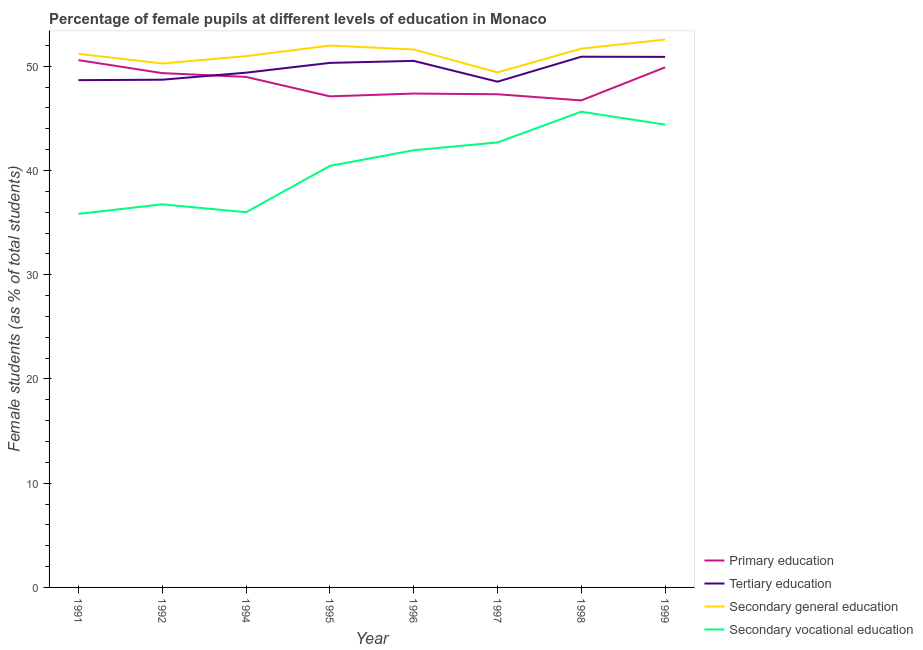How many different coloured lines are there?
Make the answer very short. 4. Does the line corresponding to percentage of female students in secondary education intersect with the line corresponding to percentage of female students in secondary vocational education?
Your answer should be very brief. No. What is the percentage of female students in secondary vocational education in 1998?
Offer a very short reply. 45.64. Across all years, what is the maximum percentage of female students in tertiary education?
Provide a succinct answer. 50.92. Across all years, what is the minimum percentage of female students in secondary vocational education?
Offer a terse response. 35.84. In which year was the percentage of female students in tertiary education maximum?
Make the answer very short. 1998. What is the total percentage of female students in secondary vocational education in the graph?
Offer a terse response. 323.73. What is the difference between the percentage of female students in secondary education in 1992 and that in 1994?
Offer a terse response. -0.7. What is the difference between the percentage of female students in secondary education in 1991 and the percentage of female students in tertiary education in 1998?
Provide a succinct answer. 0.28. What is the average percentage of female students in secondary education per year?
Offer a terse response. 51.22. In the year 1999, what is the difference between the percentage of female students in primary education and percentage of female students in secondary education?
Offer a terse response. -2.67. In how many years, is the percentage of female students in secondary vocational education greater than 42 %?
Ensure brevity in your answer.  3. What is the ratio of the percentage of female students in secondary education in 1996 to that in 1999?
Make the answer very short. 0.98. Is the percentage of female students in secondary education in 1992 less than that in 1996?
Provide a succinct answer. Yes. Is the difference between the percentage of female students in tertiary education in 1991 and 1998 greater than the difference between the percentage of female students in secondary education in 1991 and 1998?
Your answer should be compact. No. What is the difference between the highest and the second highest percentage of female students in primary education?
Provide a succinct answer. 0.69. What is the difference between the highest and the lowest percentage of female students in secondary education?
Give a very brief answer. 3.15. Is the sum of the percentage of female students in secondary vocational education in 1995 and 1999 greater than the maximum percentage of female students in secondary education across all years?
Give a very brief answer. Yes. Is it the case that in every year, the sum of the percentage of female students in tertiary education and percentage of female students in secondary education is greater than the sum of percentage of female students in primary education and percentage of female students in secondary vocational education?
Your answer should be very brief. No. Is it the case that in every year, the sum of the percentage of female students in primary education and percentage of female students in tertiary education is greater than the percentage of female students in secondary education?
Your answer should be very brief. Yes. Does the percentage of female students in secondary vocational education monotonically increase over the years?
Offer a terse response. No. How many years are there in the graph?
Keep it short and to the point. 8. What is the difference between two consecutive major ticks on the Y-axis?
Your response must be concise. 10. Does the graph contain grids?
Ensure brevity in your answer.  No. How many legend labels are there?
Offer a terse response. 4. How are the legend labels stacked?
Offer a very short reply. Vertical. What is the title of the graph?
Provide a succinct answer. Percentage of female pupils at different levels of education in Monaco. Does "International Monetary Fund" appear as one of the legend labels in the graph?
Provide a short and direct response. No. What is the label or title of the X-axis?
Your response must be concise. Year. What is the label or title of the Y-axis?
Ensure brevity in your answer.  Female students (as % of total students). What is the Female students (as % of total students) in Primary education in 1991?
Your answer should be very brief. 50.59. What is the Female students (as % of total students) of Tertiary education in 1991?
Provide a short and direct response. 48.67. What is the Female students (as % of total students) of Secondary general education in 1991?
Make the answer very short. 51.2. What is the Female students (as % of total students) in Secondary vocational education in 1991?
Keep it short and to the point. 35.84. What is the Female students (as % of total students) of Primary education in 1992?
Make the answer very short. 49.35. What is the Female students (as % of total students) of Tertiary education in 1992?
Make the answer very short. 48.71. What is the Female students (as % of total students) in Secondary general education in 1992?
Provide a succinct answer. 50.27. What is the Female students (as % of total students) in Secondary vocational education in 1992?
Keep it short and to the point. 36.76. What is the Female students (as % of total students) in Primary education in 1994?
Give a very brief answer. 48.98. What is the Female students (as % of total students) of Tertiary education in 1994?
Offer a very short reply. 49.39. What is the Female students (as % of total students) of Secondary general education in 1994?
Your response must be concise. 50.98. What is the Female students (as % of total students) of Primary education in 1995?
Make the answer very short. 47.12. What is the Female students (as % of total students) in Tertiary education in 1995?
Offer a very short reply. 50.33. What is the Female students (as % of total students) in Secondary general education in 1995?
Offer a terse response. 51.99. What is the Female students (as % of total students) of Secondary vocational education in 1995?
Make the answer very short. 40.44. What is the Female students (as % of total students) of Primary education in 1996?
Keep it short and to the point. 47.39. What is the Female students (as % of total students) in Tertiary education in 1996?
Ensure brevity in your answer.  50.52. What is the Female students (as % of total students) in Secondary general education in 1996?
Your answer should be compact. 51.61. What is the Female students (as % of total students) of Secondary vocational education in 1996?
Make the answer very short. 41.95. What is the Female students (as % of total students) of Primary education in 1997?
Your answer should be very brief. 47.32. What is the Female students (as % of total students) of Tertiary education in 1997?
Make the answer very short. 48.52. What is the Female students (as % of total students) in Secondary general education in 1997?
Your response must be concise. 49.42. What is the Female students (as % of total students) in Secondary vocational education in 1997?
Your answer should be compact. 42.69. What is the Female students (as % of total students) in Primary education in 1998?
Your answer should be compact. 46.73. What is the Female students (as % of total students) in Tertiary education in 1998?
Your answer should be compact. 50.92. What is the Female students (as % of total students) in Secondary general education in 1998?
Make the answer very short. 51.7. What is the Female students (as % of total students) of Secondary vocational education in 1998?
Offer a very short reply. 45.64. What is the Female students (as % of total students) of Primary education in 1999?
Offer a terse response. 49.9. What is the Female students (as % of total students) in Tertiary education in 1999?
Keep it short and to the point. 50.9. What is the Female students (as % of total students) in Secondary general education in 1999?
Provide a short and direct response. 52.57. What is the Female students (as % of total students) of Secondary vocational education in 1999?
Make the answer very short. 44.4. Across all years, what is the maximum Female students (as % of total students) in Primary education?
Ensure brevity in your answer.  50.59. Across all years, what is the maximum Female students (as % of total students) of Tertiary education?
Make the answer very short. 50.92. Across all years, what is the maximum Female students (as % of total students) in Secondary general education?
Offer a terse response. 52.57. Across all years, what is the maximum Female students (as % of total students) in Secondary vocational education?
Ensure brevity in your answer.  45.64. Across all years, what is the minimum Female students (as % of total students) of Primary education?
Provide a succinct answer. 46.73. Across all years, what is the minimum Female students (as % of total students) in Tertiary education?
Provide a succinct answer. 48.52. Across all years, what is the minimum Female students (as % of total students) of Secondary general education?
Offer a very short reply. 49.42. Across all years, what is the minimum Female students (as % of total students) of Secondary vocational education?
Offer a very short reply. 35.84. What is the total Female students (as % of total students) in Primary education in the graph?
Keep it short and to the point. 387.37. What is the total Female students (as % of total students) of Tertiary education in the graph?
Offer a very short reply. 397.97. What is the total Female students (as % of total students) of Secondary general education in the graph?
Your answer should be very brief. 409.72. What is the total Female students (as % of total students) in Secondary vocational education in the graph?
Provide a succinct answer. 323.73. What is the difference between the Female students (as % of total students) of Primary education in 1991 and that in 1992?
Give a very brief answer. 1.25. What is the difference between the Female students (as % of total students) in Tertiary education in 1991 and that in 1992?
Make the answer very short. -0.04. What is the difference between the Female students (as % of total students) of Secondary general education in 1991 and that in 1992?
Ensure brevity in your answer.  0.92. What is the difference between the Female students (as % of total students) in Secondary vocational education in 1991 and that in 1992?
Your response must be concise. -0.92. What is the difference between the Female students (as % of total students) of Primary education in 1991 and that in 1994?
Make the answer very short. 1.61. What is the difference between the Female students (as % of total students) in Tertiary education in 1991 and that in 1994?
Offer a very short reply. -0.72. What is the difference between the Female students (as % of total students) in Secondary general education in 1991 and that in 1994?
Give a very brief answer. 0.22. What is the difference between the Female students (as % of total students) of Secondary vocational education in 1991 and that in 1994?
Provide a short and direct response. -0.16. What is the difference between the Female students (as % of total students) of Primary education in 1991 and that in 1995?
Your answer should be compact. 3.48. What is the difference between the Female students (as % of total students) of Tertiary education in 1991 and that in 1995?
Provide a succinct answer. -1.66. What is the difference between the Female students (as % of total students) in Secondary general education in 1991 and that in 1995?
Provide a short and direct response. -0.79. What is the difference between the Female students (as % of total students) in Secondary vocational education in 1991 and that in 1995?
Your response must be concise. -4.6. What is the difference between the Female students (as % of total students) of Primary education in 1991 and that in 1996?
Provide a short and direct response. 3.21. What is the difference between the Female students (as % of total students) of Tertiary education in 1991 and that in 1996?
Your response must be concise. -1.85. What is the difference between the Female students (as % of total students) of Secondary general education in 1991 and that in 1996?
Offer a very short reply. -0.42. What is the difference between the Female students (as % of total students) of Secondary vocational education in 1991 and that in 1996?
Provide a short and direct response. -6.11. What is the difference between the Female students (as % of total students) in Primary education in 1991 and that in 1997?
Offer a terse response. 3.28. What is the difference between the Female students (as % of total students) of Tertiary education in 1991 and that in 1997?
Give a very brief answer. 0.15. What is the difference between the Female students (as % of total students) of Secondary general education in 1991 and that in 1997?
Your response must be concise. 1.78. What is the difference between the Female students (as % of total students) of Secondary vocational education in 1991 and that in 1997?
Provide a short and direct response. -6.85. What is the difference between the Female students (as % of total students) in Primary education in 1991 and that in 1998?
Your response must be concise. 3.86. What is the difference between the Female students (as % of total students) of Tertiary education in 1991 and that in 1998?
Your answer should be very brief. -2.25. What is the difference between the Female students (as % of total students) of Secondary general education in 1991 and that in 1998?
Make the answer very short. -0.5. What is the difference between the Female students (as % of total students) of Secondary vocational education in 1991 and that in 1998?
Your answer should be compact. -9.8. What is the difference between the Female students (as % of total students) of Primary education in 1991 and that in 1999?
Your answer should be compact. 0.69. What is the difference between the Female students (as % of total students) of Tertiary education in 1991 and that in 1999?
Keep it short and to the point. -2.23. What is the difference between the Female students (as % of total students) of Secondary general education in 1991 and that in 1999?
Ensure brevity in your answer.  -1.37. What is the difference between the Female students (as % of total students) of Secondary vocational education in 1991 and that in 1999?
Keep it short and to the point. -8.56. What is the difference between the Female students (as % of total students) in Primary education in 1992 and that in 1994?
Offer a terse response. 0.37. What is the difference between the Female students (as % of total students) in Tertiary education in 1992 and that in 1994?
Your answer should be compact. -0.68. What is the difference between the Female students (as % of total students) in Secondary general education in 1992 and that in 1994?
Provide a short and direct response. -0.7. What is the difference between the Female students (as % of total students) in Secondary vocational education in 1992 and that in 1994?
Provide a short and direct response. 0.76. What is the difference between the Female students (as % of total students) in Primary education in 1992 and that in 1995?
Your answer should be very brief. 2.23. What is the difference between the Female students (as % of total students) in Tertiary education in 1992 and that in 1995?
Offer a terse response. -1.61. What is the difference between the Female students (as % of total students) in Secondary general education in 1992 and that in 1995?
Your answer should be compact. -1.72. What is the difference between the Female students (as % of total students) of Secondary vocational education in 1992 and that in 1995?
Offer a very short reply. -3.69. What is the difference between the Female students (as % of total students) of Primary education in 1992 and that in 1996?
Keep it short and to the point. 1.96. What is the difference between the Female students (as % of total students) in Tertiary education in 1992 and that in 1996?
Make the answer very short. -1.81. What is the difference between the Female students (as % of total students) of Secondary general education in 1992 and that in 1996?
Keep it short and to the point. -1.34. What is the difference between the Female students (as % of total students) in Secondary vocational education in 1992 and that in 1996?
Your answer should be very brief. -5.19. What is the difference between the Female students (as % of total students) of Primary education in 1992 and that in 1997?
Provide a short and direct response. 2.03. What is the difference between the Female students (as % of total students) in Tertiary education in 1992 and that in 1997?
Provide a succinct answer. 0.19. What is the difference between the Female students (as % of total students) of Secondary general education in 1992 and that in 1997?
Offer a terse response. 0.86. What is the difference between the Female students (as % of total students) in Secondary vocational education in 1992 and that in 1997?
Your answer should be compact. -5.94. What is the difference between the Female students (as % of total students) in Primary education in 1992 and that in 1998?
Offer a terse response. 2.62. What is the difference between the Female students (as % of total students) of Tertiary education in 1992 and that in 1998?
Your response must be concise. -2.21. What is the difference between the Female students (as % of total students) of Secondary general education in 1992 and that in 1998?
Offer a terse response. -1.42. What is the difference between the Female students (as % of total students) in Secondary vocational education in 1992 and that in 1998?
Make the answer very short. -8.89. What is the difference between the Female students (as % of total students) of Primary education in 1992 and that in 1999?
Your response must be concise. -0.55. What is the difference between the Female students (as % of total students) in Tertiary education in 1992 and that in 1999?
Provide a short and direct response. -2.19. What is the difference between the Female students (as % of total students) of Secondary general education in 1992 and that in 1999?
Provide a short and direct response. -2.29. What is the difference between the Female students (as % of total students) of Secondary vocational education in 1992 and that in 1999?
Offer a very short reply. -7.64. What is the difference between the Female students (as % of total students) in Primary education in 1994 and that in 1995?
Ensure brevity in your answer.  1.86. What is the difference between the Female students (as % of total students) of Tertiary education in 1994 and that in 1995?
Your answer should be compact. -0.94. What is the difference between the Female students (as % of total students) in Secondary general education in 1994 and that in 1995?
Offer a terse response. -1.01. What is the difference between the Female students (as % of total students) of Secondary vocational education in 1994 and that in 1995?
Give a very brief answer. -4.44. What is the difference between the Female students (as % of total students) in Primary education in 1994 and that in 1996?
Ensure brevity in your answer.  1.6. What is the difference between the Female students (as % of total students) of Tertiary education in 1994 and that in 1996?
Provide a succinct answer. -1.13. What is the difference between the Female students (as % of total students) in Secondary general education in 1994 and that in 1996?
Offer a very short reply. -0.64. What is the difference between the Female students (as % of total students) of Secondary vocational education in 1994 and that in 1996?
Provide a succinct answer. -5.95. What is the difference between the Female students (as % of total students) of Primary education in 1994 and that in 1997?
Offer a terse response. 1.66. What is the difference between the Female students (as % of total students) of Tertiary education in 1994 and that in 1997?
Ensure brevity in your answer.  0.86. What is the difference between the Female students (as % of total students) in Secondary general education in 1994 and that in 1997?
Give a very brief answer. 1.56. What is the difference between the Female students (as % of total students) of Secondary vocational education in 1994 and that in 1997?
Give a very brief answer. -6.69. What is the difference between the Female students (as % of total students) of Primary education in 1994 and that in 1998?
Offer a terse response. 2.25. What is the difference between the Female students (as % of total students) of Tertiary education in 1994 and that in 1998?
Keep it short and to the point. -1.53. What is the difference between the Female students (as % of total students) in Secondary general education in 1994 and that in 1998?
Offer a very short reply. -0.72. What is the difference between the Female students (as % of total students) of Secondary vocational education in 1994 and that in 1998?
Offer a terse response. -9.64. What is the difference between the Female students (as % of total students) in Primary education in 1994 and that in 1999?
Make the answer very short. -0.92. What is the difference between the Female students (as % of total students) of Tertiary education in 1994 and that in 1999?
Offer a very short reply. -1.52. What is the difference between the Female students (as % of total students) in Secondary general education in 1994 and that in 1999?
Offer a very short reply. -1.59. What is the difference between the Female students (as % of total students) in Secondary vocational education in 1994 and that in 1999?
Give a very brief answer. -8.4. What is the difference between the Female students (as % of total students) in Primary education in 1995 and that in 1996?
Your answer should be very brief. -0.27. What is the difference between the Female students (as % of total students) in Tertiary education in 1995 and that in 1996?
Your answer should be compact. -0.19. What is the difference between the Female students (as % of total students) of Secondary general education in 1995 and that in 1996?
Make the answer very short. 0.38. What is the difference between the Female students (as % of total students) in Secondary vocational education in 1995 and that in 1996?
Make the answer very short. -1.5. What is the difference between the Female students (as % of total students) in Primary education in 1995 and that in 1997?
Make the answer very short. -0.2. What is the difference between the Female students (as % of total students) in Tertiary education in 1995 and that in 1997?
Keep it short and to the point. 1.8. What is the difference between the Female students (as % of total students) in Secondary general education in 1995 and that in 1997?
Ensure brevity in your answer.  2.57. What is the difference between the Female students (as % of total students) of Secondary vocational education in 1995 and that in 1997?
Offer a terse response. -2.25. What is the difference between the Female students (as % of total students) in Primary education in 1995 and that in 1998?
Your answer should be very brief. 0.39. What is the difference between the Female students (as % of total students) in Tertiary education in 1995 and that in 1998?
Offer a terse response. -0.59. What is the difference between the Female students (as % of total students) in Secondary general education in 1995 and that in 1998?
Your answer should be compact. 0.29. What is the difference between the Female students (as % of total students) of Secondary vocational education in 1995 and that in 1998?
Ensure brevity in your answer.  -5.2. What is the difference between the Female students (as % of total students) in Primary education in 1995 and that in 1999?
Ensure brevity in your answer.  -2.78. What is the difference between the Female students (as % of total students) of Tertiary education in 1995 and that in 1999?
Your response must be concise. -0.58. What is the difference between the Female students (as % of total students) in Secondary general education in 1995 and that in 1999?
Ensure brevity in your answer.  -0.58. What is the difference between the Female students (as % of total students) in Secondary vocational education in 1995 and that in 1999?
Your answer should be compact. -3.96. What is the difference between the Female students (as % of total students) in Primary education in 1996 and that in 1997?
Offer a very short reply. 0.07. What is the difference between the Female students (as % of total students) in Tertiary education in 1996 and that in 1997?
Your response must be concise. 2. What is the difference between the Female students (as % of total students) of Secondary general education in 1996 and that in 1997?
Provide a short and direct response. 2.2. What is the difference between the Female students (as % of total students) in Secondary vocational education in 1996 and that in 1997?
Provide a short and direct response. -0.74. What is the difference between the Female students (as % of total students) of Primary education in 1996 and that in 1998?
Your answer should be very brief. 0.66. What is the difference between the Female students (as % of total students) of Tertiary education in 1996 and that in 1998?
Your answer should be compact. -0.4. What is the difference between the Female students (as % of total students) of Secondary general education in 1996 and that in 1998?
Your answer should be compact. -0.09. What is the difference between the Female students (as % of total students) in Secondary vocational education in 1996 and that in 1998?
Offer a terse response. -3.7. What is the difference between the Female students (as % of total students) of Primary education in 1996 and that in 1999?
Make the answer very short. -2.52. What is the difference between the Female students (as % of total students) in Tertiary education in 1996 and that in 1999?
Your answer should be compact. -0.39. What is the difference between the Female students (as % of total students) of Secondary general education in 1996 and that in 1999?
Your answer should be compact. -0.96. What is the difference between the Female students (as % of total students) in Secondary vocational education in 1996 and that in 1999?
Ensure brevity in your answer.  -2.45. What is the difference between the Female students (as % of total students) in Primary education in 1997 and that in 1998?
Your answer should be very brief. 0.59. What is the difference between the Female students (as % of total students) in Tertiary education in 1997 and that in 1998?
Offer a terse response. -2.4. What is the difference between the Female students (as % of total students) of Secondary general education in 1997 and that in 1998?
Ensure brevity in your answer.  -2.28. What is the difference between the Female students (as % of total students) of Secondary vocational education in 1997 and that in 1998?
Your answer should be compact. -2.95. What is the difference between the Female students (as % of total students) in Primary education in 1997 and that in 1999?
Give a very brief answer. -2.58. What is the difference between the Female students (as % of total students) in Tertiary education in 1997 and that in 1999?
Make the answer very short. -2.38. What is the difference between the Female students (as % of total students) of Secondary general education in 1997 and that in 1999?
Ensure brevity in your answer.  -3.15. What is the difference between the Female students (as % of total students) in Secondary vocational education in 1997 and that in 1999?
Offer a terse response. -1.71. What is the difference between the Female students (as % of total students) in Primary education in 1998 and that in 1999?
Your answer should be very brief. -3.17. What is the difference between the Female students (as % of total students) in Tertiary education in 1998 and that in 1999?
Your answer should be compact. 0.01. What is the difference between the Female students (as % of total students) in Secondary general education in 1998 and that in 1999?
Your answer should be very brief. -0.87. What is the difference between the Female students (as % of total students) in Secondary vocational education in 1998 and that in 1999?
Your response must be concise. 1.24. What is the difference between the Female students (as % of total students) in Primary education in 1991 and the Female students (as % of total students) in Tertiary education in 1992?
Offer a terse response. 1.88. What is the difference between the Female students (as % of total students) of Primary education in 1991 and the Female students (as % of total students) of Secondary general education in 1992?
Give a very brief answer. 0.32. What is the difference between the Female students (as % of total students) in Primary education in 1991 and the Female students (as % of total students) in Secondary vocational education in 1992?
Ensure brevity in your answer.  13.84. What is the difference between the Female students (as % of total students) in Tertiary education in 1991 and the Female students (as % of total students) in Secondary general education in 1992?
Make the answer very short. -1.6. What is the difference between the Female students (as % of total students) of Tertiary education in 1991 and the Female students (as % of total students) of Secondary vocational education in 1992?
Give a very brief answer. 11.91. What is the difference between the Female students (as % of total students) of Secondary general education in 1991 and the Female students (as % of total students) of Secondary vocational education in 1992?
Ensure brevity in your answer.  14.44. What is the difference between the Female students (as % of total students) of Primary education in 1991 and the Female students (as % of total students) of Tertiary education in 1994?
Offer a very short reply. 1.2. What is the difference between the Female students (as % of total students) of Primary education in 1991 and the Female students (as % of total students) of Secondary general education in 1994?
Keep it short and to the point. -0.38. What is the difference between the Female students (as % of total students) of Primary education in 1991 and the Female students (as % of total students) of Secondary vocational education in 1994?
Keep it short and to the point. 14.59. What is the difference between the Female students (as % of total students) in Tertiary education in 1991 and the Female students (as % of total students) in Secondary general education in 1994?
Provide a succinct answer. -2.31. What is the difference between the Female students (as % of total students) in Tertiary education in 1991 and the Female students (as % of total students) in Secondary vocational education in 1994?
Make the answer very short. 12.67. What is the difference between the Female students (as % of total students) in Secondary general education in 1991 and the Female students (as % of total students) in Secondary vocational education in 1994?
Make the answer very short. 15.2. What is the difference between the Female students (as % of total students) in Primary education in 1991 and the Female students (as % of total students) in Tertiary education in 1995?
Your answer should be very brief. 0.27. What is the difference between the Female students (as % of total students) in Primary education in 1991 and the Female students (as % of total students) in Secondary general education in 1995?
Offer a terse response. -1.4. What is the difference between the Female students (as % of total students) in Primary education in 1991 and the Female students (as % of total students) in Secondary vocational education in 1995?
Keep it short and to the point. 10.15. What is the difference between the Female students (as % of total students) in Tertiary education in 1991 and the Female students (as % of total students) in Secondary general education in 1995?
Ensure brevity in your answer.  -3.32. What is the difference between the Female students (as % of total students) in Tertiary education in 1991 and the Female students (as % of total students) in Secondary vocational education in 1995?
Your answer should be very brief. 8.23. What is the difference between the Female students (as % of total students) of Secondary general education in 1991 and the Female students (as % of total students) of Secondary vocational education in 1995?
Your answer should be compact. 10.75. What is the difference between the Female students (as % of total students) of Primary education in 1991 and the Female students (as % of total students) of Tertiary education in 1996?
Your response must be concise. 0.07. What is the difference between the Female students (as % of total students) of Primary education in 1991 and the Female students (as % of total students) of Secondary general education in 1996?
Give a very brief answer. -1.02. What is the difference between the Female students (as % of total students) of Primary education in 1991 and the Female students (as % of total students) of Secondary vocational education in 1996?
Provide a short and direct response. 8.64. What is the difference between the Female students (as % of total students) of Tertiary education in 1991 and the Female students (as % of total students) of Secondary general education in 1996?
Keep it short and to the point. -2.94. What is the difference between the Female students (as % of total students) of Tertiary education in 1991 and the Female students (as % of total students) of Secondary vocational education in 1996?
Provide a short and direct response. 6.72. What is the difference between the Female students (as % of total students) of Secondary general education in 1991 and the Female students (as % of total students) of Secondary vocational education in 1996?
Provide a succinct answer. 9.25. What is the difference between the Female students (as % of total students) of Primary education in 1991 and the Female students (as % of total students) of Tertiary education in 1997?
Make the answer very short. 2.07. What is the difference between the Female students (as % of total students) of Primary education in 1991 and the Female students (as % of total students) of Secondary general education in 1997?
Offer a very short reply. 1.18. What is the difference between the Female students (as % of total students) of Primary education in 1991 and the Female students (as % of total students) of Secondary vocational education in 1997?
Provide a short and direct response. 7.9. What is the difference between the Female students (as % of total students) in Tertiary education in 1991 and the Female students (as % of total students) in Secondary general education in 1997?
Your response must be concise. -0.74. What is the difference between the Female students (as % of total students) of Tertiary education in 1991 and the Female students (as % of total students) of Secondary vocational education in 1997?
Make the answer very short. 5.98. What is the difference between the Female students (as % of total students) in Secondary general education in 1991 and the Female students (as % of total students) in Secondary vocational education in 1997?
Ensure brevity in your answer.  8.5. What is the difference between the Female students (as % of total students) in Primary education in 1991 and the Female students (as % of total students) in Tertiary education in 1998?
Offer a terse response. -0.33. What is the difference between the Female students (as % of total students) in Primary education in 1991 and the Female students (as % of total students) in Secondary general education in 1998?
Give a very brief answer. -1.1. What is the difference between the Female students (as % of total students) in Primary education in 1991 and the Female students (as % of total students) in Secondary vocational education in 1998?
Your answer should be very brief. 4.95. What is the difference between the Female students (as % of total students) of Tertiary education in 1991 and the Female students (as % of total students) of Secondary general education in 1998?
Offer a terse response. -3.03. What is the difference between the Female students (as % of total students) of Tertiary education in 1991 and the Female students (as % of total students) of Secondary vocational education in 1998?
Your response must be concise. 3.03. What is the difference between the Female students (as % of total students) in Secondary general education in 1991 and the Female students (as % of total students) in Secondary vocational education in 1998?
Provide a short and direct response. 5.55. What is the difference between the Female students (as % of total students) in Primary education in 1991 and the Female students (as % of total students) in Tertiary education in 1999?
Your answer should be very brief. -0.31. What is the difference between the Female students (as % of total students) in Primary education in 1991 and the Female students (as % of total students) in Secondary general education in 1999?
Provide a short and direct response. -1.98. What is the difference between the Female students (as % of total students) of Primary education in 1991 and the Female students (as % of total students) of Secondary vocational education in 1999?
Your response must be concise. 6.19. What is the difference between the Female students (as % of total students) in Tertiary education in 1991 and the Female students (as % of total students) in Secondary general education in 1999?
Give a very brief answer. -3.9. What is the difference between the Female students (as % of total students) in Tertiary education in 1991 and the Female students (as % of total students) in Secondary vocational education in 1999?
Offer a terse response. 4.27. What is the difference between the Female students (as % of total students) of Secondary general education in 1991 and the Female students (as % of total students) of Secondary vocational education in 1999?
Your answer should be very brief. 6.79. What is the difference between the Female students (as % of total students) in Primary education in 1992 and the Female students (as % of total students) in Tertiary education in 1994?
Provide a short and direct response. -0.04. What is the difference between the Female students (as % of total students) of Primary education in 1992 and the Female students (as % of total students) of Secondary general education in 1994?
Offer a terse response. -1.63. What is the difference between the Female students (as % of total students) in Primary education in 1992 and the Female students (as % of total students) in Secondary vocational education in 1994?
Give a very brief answer. 13.35. What is the difference between the Female students (as % of total students) in Tertiary education in 1992 and the Female students (as % of total students) in Secondary general education in 1994?
Keep it short and to the point. -2.26. What is the difference between the Female students (as % of total students) of Tertiary education in 1992 and the Female students (as % of total students) of Secondary vocational education in 1994?
Ensure brevity in your answer.  12.71. What is the difference between the Female students (as % of total students) of Secondary general education in 1992 and the Female students (as % of total students) of Secondary vocational education in 1994?
Give a very brief answer. 14.27. What is the difference between the Female students (as % of total students) of Primary education in 1992 and the Female students (as % of total students) of Tertiary education in 1995?
Your answer should be very brief. -0.98. What is the difference between the Female students (as % of total students) in Primary education in 1992 and the Female students (as % of total students) in Secondary general education in 1995?
Offer a very short reply. -2.64. What is the difference between the Female students (as % of total students) of Primary education in 1992 and the Female students (as % of total students) of Secondary vocational education in 1995?
Ensure brevity in your answer.  8.9. What is the difference between the Female students (as % of total students) in Tertiary education in 1992 and the Female students (as % of total students) in Secondary general education in 1995?
Provide a short and direct response. -3.28. What is the difference between the Female students (as % of total students) in Tertiary education in 1992 and the Female students (as % of total students) in Secondary vocational education in 1995?
Ensure brevity in your answer.  8.27. What is the difference between the Female students (as % of total students) of Secondary general education in 1992 and the Female students (as % of total students) of Secondary vocational education in 1995?
Offer a very short reply. 9.83. What is the difference between the Female students (as % of total students) in Primary education in 1992 and the Female students (as % of total students) in Tertiary education in 1996?
Keep it short and to the point. -1.17. What is the difference between the Female students (as % of total students) of Primary education in 1992 and the Female students (as % of total students) of Secondary general education in 1996?
Offer a very short reply. -2.26. What is the difference between the Female students (as % of total students) in Primary education in 1992 and the Female students (as % of total students) in Secondary vocational education in 1996?
Your response must be concise. 7.4. What is the difference between the Female students (as % of total students) of Tertiary education in 1992 and the Female students (as % of total students) of Secondary general education in 1996?
Provide a succinct answer. -2.9. What is the difference between the Female students (as % of total students) in Tertiary education in 1992 and the Female students (as % of total students) in Secondary vocational education in 1996?
Your response must be concise. 6.76. What is the difference between the Female students (as % of total students) in Secondary general education in 1992 and the Female students (as % of total students) in Secondary vocational education in 1996?
Provide a succinct answer. 8.32. What is the difference between the Female students (as % of total students) in Primary education in 1992 and the Female students (as % of total students) in Tertiary education in 1997?
Provide a succinct answer. 0.82. What is the difference between the Female students (as % of total students) of Primary education in 1992 and the Female students (as % of total students) of Secondary general education in 1997?
Provide a short and direct response. -0.07. What is the difference between the Female students (as % of total students) of Primary education in 1992 and the Female students (as % of total students) of Secondary vocational education in 1997?
Make the answer very short. 6.65. What is the difference between the Female students (as % of total students) in Tertiary education in 1992 and the Female students (as % of total students) in Secondary general education in 1997?
Provide a short and direct response. -0.7. What is the difference between the Female students (as % of total students) of Tertiary education in 1992 and the Female students (as % of total students) of Secondary vocational education in 1997?
Your answer should be very brief. 6.02. What is the difference between the Female students (as % of total students) in Secondary general education in 1992 and the Female students (as % of total students) in Secondary vocational education in 1997?
Make the answer very short. 7.58. What is the difference between the Female students (as % of total students) of Primary education in 1992 and the Female students (as % of total students) of Tertiary education in 1998?
Offer a terse response. -1.57. What is the difference between the Female students (as % of total students) of Primary education in 1992 and the Female students (as % of total students) of Secondary general education in 1998?
Provide a succinct answer. -2.35. What is the difference between the Female students (as % of total students) of Primary education in 1992 and the Female students (as % of total students) of Secondary vocational education in 1998?
Offer a terse response. 3.7. What is the difference between the Female students (as % of total students) in Tertiary education in 1992 and the Female students (as % of total students) in Secondary general education in 1998?
Give a very brief answer. -2.98. What is the difference between the Female students (as % of total students) in Tertiary education in 1992 and the Female students (as % of total students) in Secondary vocational education in 1998?
Your answer should be compact. 3.07. What is the difference between the Female students (as % of total students) of Secondary general education in 1992 and the Female students (as % of total students) of Secondary vocational education in 1998?
Your answer should be compact. 4.63. What is the difference between the Female students (as % of total students) of Primary education in 1992 and the Female students (as % of total students) of Tertiary education in 1999?
Offer a terse response. -1.56. What is the difference between the Female students (as % of total students) in Primary education in 1992 and the Female students (as % of total students) in Secondary general education in 1999?
Make the answer very short. -3.22. What is the difference between the Female students (as % of total students) of Primary education in 1992 and the Female students (as % of total students) of Secondary vocational education in 1999?
Your answer should be compact. 4.95. What is the difference between the Female students (as % of total students) of Tertiary education in 1992 and the Female students (as % of total students) of Secondary general education in 1999?
Provide a succinct answer. -3.85. What is the difference between the Female students (as % of total students) of Tertiary education in 1992 and the Female students (as % of total students) of Secondary vocational education in 1999?
Your response must be concise. 4.31. What is the difference between the Female students (as % of total students) of Secondary general education in 1992 and the Female students (as % of total students) of Secondary vocational education in 1999?
Your answer should be compact. 5.87. What is the difference between the Female students (as % of total students) in Primary education in 1994 and the Female students (as % of total students) in Tertiary education in 1995?
Offer a terse response. -1.35. What is the difference between the Female students (as % of total students) of Primary education in 1994 and the Female students (as % of total students) of Secondary general education in 1995?
Make the answer very short. -3.01. What is the difference between the Female students (as % of total students) of Primary education in 1994 and the Female students (as % of total students) of Secondary vocational education in 1995?
Ensure brevity in your answer.  8.54. What is the difference between the Female students (as % of total students) of Tertiary education in 1994 and the Female students (as % of total students) of Secondary general education in 1995?
Your answer should be compact. -2.6. What is the difference between the Female students (as % of total students) in Tertiary education in 1994 and the Female students (as % of total students) in Secondary vocational education in 1995?
Offer a terse response. 8.94. What is the difference between the Female students (as % of total students) in Secondary general education in 1994 and the Female students (as % of total students) in Secondary vocational education in 1995?
Offer a very short reply. 10.53. What is the difference between the Female students (as % of total students) in Primary education in 1994 and the Female students (as % of total students) in Tertiary education in 1996?
Your response must be concise. -1.54. What is the difference between the Female students (as % of total students) of Primary education in 1994 and the Female students (as % of total students) of Secondary general education in 1996?
Your answer should be compact. -2.63. What is the difference between the Female students (as % of total students) of Primary education in 1994 and the Female students (as % of total students) of Secondary vocational education in 1996?
Offer a terse response. 7.03. What is the difference between the Female students (as % of total students) of Tertiary education in 1994 and the Female students (as % of total students) of Secondary general education in 1996?
Offer a very short reply. -2.22. What is the difference between the Female students (as % of total students) in Tertiary education in 1994 and the Female students (as % of total students) in Secondary vocational education in 1996?
Make the answer very short. 7.44. What is the difference between the Female students (as % of total students) of Secondary general education in 1994 and the Female students (as % of total students) of Secondary vocational education in 1996?
Make the answer very short. 9.03. What is the difference between the Female students (as % of total students) of Primary education in 1994 and the Female students (as % of total students) of Tertiary education in 1997?
Your answer should be compact. 0.46. What is the difference between the Female students (as % of total students) in Primary education in 1994 and the Female students (as % of total students) in Secondary general education in 1997?
Your response must be concise. -0.43. What is the difference between the Female students (as % of total students) in Primary education in 1994 and the Female students (as % of total students) in Secondary vocational education in 1997?
Make the answer very short. 6.29. What is the difference between the Female students (as % of total students) in Tertiary education in 1994 and the Female students (as % of total students) in Secondary general education in 1997?
Provide a short and direct response. -0.03. What is the difference between the Female students (as % of total students) in Tertiary education in 1994 and the Female students (as % of total students) in Secondary vocational education in 1997?
Your answer should be compact. 6.7. What is the difference between the Female students (as % of total students) of Secondary general education in 1994 and the Female students (as % of total students) of Secondary vocational education in 1997?
Make the answer very short. 8.28. What is the difference between the Female students (as % of total students) in Primary education in 1994 and the Female students (as % of total students) in Tertiary education in 1998?
Keep it short and to the point. -1.94. What is the difference between the Female students (as % of total students) in Primary education in 1994 and the Female students (as % of total students) in Secondary general education in 1998?
Your answer should be compact. -2.72. What is the difference between the Female students (as % of total students) of Primary education in 1994 and the Female students (as % of total students) of Secondary vocational education in 1998?
Offer a terse response. 3.34. What is the difference between the Female students (as % of total students) in Tertiary education in 1994 and the Female students (as % of total students) in Secondary general education in 1998?
Keep it short and to the point. -2.31. What is the difference between the Female students (as % of total students) of Tertiary education in 1994 and the Female students (as % of total students) of Secondary vocational education in 1998?
Provide a succinct answer. 3.74. What is the difference between the Female students (as % of total students) in Secondary general education in 1994 and the Female students (as % of total students) in Secondary vocational education in 1998?
Give a very brief answer. 5.33. What is the difference between the Female students (as % of total students) in Primary education in 1994 and the Female students (as % of total students) in Tertiary education in 1999?
Offer a terse response. -1.92. What is the difference between the Female students (as % of total students) in Primary education in 1994 and the Female students (as % of total students) in Secondary general education in 1999?
Your answer should be very brief. -3.59. What is the difference between the Female students (as % of total students) of Primary education in 1994 and the Female students (as % of total students) of Secondary vocational education in 1999?
Provide a short and direct response. 4.58. What is the difference between the Female students (as % of total students) of Tertiary education in 1994 and the Female students (as % of total students) of Secondary general education in 1999?
Your answer should be compact. -3.18. What is the difference between the Female students (as % of total students) of Tertiary education in 1994 and the Female students (as % of total students) of Secondary vocational education in 1999?
Make the answer very short. 4.99. What is the difference between the Female students (as % of total students) of Secondary general education in 1994 and the Female students (as % of total students) of Secondary vocational education in 1999?
Your answer should be compact. 6.57. What is the difference between the Female students (as % of total students) of Primary education in 1995 and the Female students (as % of total students) of Tertiary education in 1996?
Ensure brevity in your answer.  -3.4. What is the difference between the Female students (as % of total students) in Primary education in 1995 and the Female students (as % of total students) in Secondary general education in 1996?
Your answer should be compact. -4.5. What is the difference between the Female students (as % of total students) of Primary education in 1995 and the Female students (as % of total students) of Secondary vocational education in 1996?
Make the answer very short. 5.17. What is the difference between the Female students (as % of total students) in Tertiary education in 1995 and the Female students (as % of total students) in Secondary general education in 1996?
Offer a very short reply. -1.28. What is the difference between the Female students (as % of total students) in Tertiary education in 1995 and the Female students (as % of total students) in Secondary vocational education in 1996?
Provide a short and direct response. 8.38. What is the difference between the Female students (as % of total students) of Secondary general education in 1995 and the Female students (as % of total students) of Secondary vocational education in 1996?
Make the answer very short. 10.04. What is the difference between the Female students (as % of total students) of Primary education in 1995 and the Female students (as % of total students) of Tertiary education in 1997?
Provide a succinct answer. -1.41. What is the difference between the Female students (as % of total students) of Primary education in 1995 and the Female students (as % of total students) of Secondary general education in 1997?
Your response must be concise. -2.3. What is the difference between the Female students (as % of total students) of Primary education in 1995 and the Female students (as % of total students) of Secondary vocational education in 1997?
Your answer should be very brief. 4.42. What is the difference between the Female students (as % of total students) of Tertiary education in 1995 and the Female students (as % of total students) of Secondary general education in 1997?
Offer a terse response. 0.91. What is the difference between the Female students (as % of total students) in Tertiary education in 1995 and the Female students (as % of total students) in Secondary vocational education in 1997?
Offer a terse response. 7.63. What is the difference between the Female students (as % of total students) of Secondary general education in 1995 and the Female students (as % of total students) of Secondary vocational education in 1997?
Ensure brevity in your answer.  9.3. What is the difference between the Female students (as % of total students) of Primary education in 1995 and the Female students (as % of total students) of Tertiary education in 1998?
Your answer should be very brief. -3.8. What is the difference between the Female students (as % of total students) of Primary education in 1995 and the Female students (as % of total students) of Secondary general education in 1998?
Your answer should be very brief. -4.58. What is the difference between the Female students (as % of total students) in Primary education in 1995 and the Female students (as % of total students) in Secondary vocational education in 1998?
Your response must be concise. 1.47. What is the difference between the Female students (as % of total students) in Tertiary education in 1995 and the Female students (as % of total students) in Secondary general education in 1998?
Your answer should be very brief. -1.37. What is the difference between the Female students (as % of total students) of Tertiary education in 1995 and the Female students (as % of total students) of Secondary vocational education in 1998?
Offer a terse response. 4.68. What is the difference between the Female students (as % of total students) of Secondary general education in 1995 and the Female students (as % of total students) of Secondary vocational education in 1998?
Provide a short and direct response. 6.35. What is the difference between the Female students (as % of total students) in Primary education in 1995 and the Female students (as % of total students) in Tertiary education in 1999?
Provide a short and direct response. -3.79. What is the difference between the Female students (as % of total students) of Primary education in 1995 and the Female students (as % of total students) of Secondary general education in 1999?
Offer a very short reply. -5.45. What is the difference between the Female students (as % of total students) in Primary education in 1995 and the Female students (as % of total students) in Secondary vocational education in 1999?
Give a very brief answer. 2.71. What is the difference between the Female students (as % of total students) in Tertiary education in 1995 and the Female students (as % of total students) in Secondary general education in 1999?
Your answer should be compact. -2.24. What is the difference between the Female students (as % of total students) in Tertiary education in 1995 and the Female students (as % of total students) in Secondary vocational education in 1999?
Give a very brief answer. 5.93. What is the difference between the Female students (as % of total students) in Secondary general education in 1995 and the Female students (as % of total students) in Secondary vocational education in 1999?
Your response must be concise. 7.59. What is the difference between the Female students (as % of total students) in Primary education in 1996 and the Female students (as % of total students) in Tertiary education in 1997?
Your answer should be very brief. -1.14. What is the difference between the Female students (as % of total students) in Primary education in 1996 and the Female students (as % of total students) in Secondary general education in 1997?
Your response must be concise. -2.03. What is the difference between the Female students (as % of total students) of Primary education in 1996 and the Female students (as % of total students) of Secondary vocational education in 1997?
Ensure brevity in your answer.  4.69. What is the difference between the Female students (as % of total students) of Tertiary education in 1996 and the Female students (as % of total students) of Secondary general education in 1997?
Your answer should be compact. 1.1. What is the difference between the Female students (as % of total students) in Tertiary education in 1996 and the Female students (as % of total students) in Secondary vocational education in 1997?
Keep it short and to the point. 7.83. What is the difference between the Female students (as % of total students) of Secondary general education in 1996 and the Female students (as % of total students) of Secondary vocational education in 1997?
Offer a terse response. 8.92. What is the difference between the Female students (as % of total students) of Primary education in 1996 and the Female students (as % of total students) of Tertiary education in 1998?
Make the answer very short. -3.53. What is the difference between the Female students (as % of total students) of Primary education in 1996 and the Female students (as % of total students) of Secondary general education in 1998?
Provide a short and direct response. -4.31. What is the difference between the Female students (as % of total students) of Primary education in 1996 and the Female students (as % of total students) of Secondary vocational education in 1998?
Ensure brevity in your answer.  1.74. What is the difference between the Female students (as % of total students) in Tertiary education in 1996 and the Female students (as % of total students) in Secondary general education in 1998?
Keep it short and to the point. -1.18. What is the difference between the Female students (as % of total students) of Tertiary education in 1996 and the Female students (as % of total students) of Secondary vocational education in 1998?
Ensure brevity in your answer.  4.88. What is the difference between the Female students (as % of total students) in Secondary general education in 1996 and the Female students (as % of total students) in Secondary vocational education in 1998?
Give a very brief answer. 5.97. What is the difference between the Female students (as % of total students) in Primary education in 1996 and the Female students (as % of total students) in Tertiary education in 1999?
Your answer should be very brief. -3.52. What is the difference between the Female students (as % of total students) of Primary education in 1996 and the Female students (as % of total students) of Secondary general education in 1999?
Provide a short and direct response. -5.18. What is the difference between the Female students (as % of total students) in Primary education in 1996 and the Female students (as % of total students) in Secondary vocational education in 1999?
Provide a short and direct response. 2.98. What is the difference between the Female students (as % of total students) of Tertiary education in 1996 and the Female students (as % of total students) of Secondary general education in 1999?
Your response must be concise. -2.05. What is the difference between the Female students (as % of total students) of Tertiary education in 1996 and the Female students (as % of total students) of Secondary vocational education in 1999?
Your answer should be very brief. 6.12. What is the difference between the Female students (as % of total students) in Secondary general education in 1996 and the Female students (as % of total students) in Secondary vocational education in 1999?
Your answer should be compact. 7.21. What is the difference between the Female students (as % of total students) in Primary education in 1997 and the Female students (as % of total students) in Tertiary education in 1998?
Your response must be concise. -3.6. What is the difference between the Female students (as % of total students) in Primary education in 1997 and the Female students (as % of total students) in Secondary general education in 1998?
Keep it short and to the point. -4.38. What is the difference between the Female students (as % of total students) in Primary education in 1997 and the Female students (as % of total students) in Secondary vocational education in 1998?
Your answer should be compact. 1.67. What is the difference between the Female students (as % of total students) in Tertiary education in 1997 and the Female students (as % of total students) in Secondary general education in 1998?
Your response must be concise. -3.17. What is the difference between the Female students (as % of total students) of Tertiary education in 1997 and the Female students (as % of total students) of Secondary vocational education in 1998?
Offer a terse response. 2.88. What is the difference between the Female students (as % of total students) in Secondary general education in 1997 and the Female students (as % of total students) in Secondary vocational education in 1998?
Your answer should be compact. 3.77. What is the difference between the Female students (as % of total students) of Primary education in 1997 and the Female students (as % of total students) of Tertiary education in 1999?
Provide a succinct answer. -3.59. What is the difference between the Female students (as % of total students) of Primary education in 1997 and the Female students (as % of total students) of Secondary general education in 1999?
Provide a short and direct response. -5.25. What is the difference between the Female students (as % of total students) in Primary education in 1997 and the Female students (as % of total students) in Secondary vocational education in 1999?
Provide a short and direct response. 2.91. What is the difference between the Female students (as % of total students) in Tertiary education in 1997 and the Female students (as % of total students) in Secondary general education in 1999?
Your response must be concise. -4.04. What is the difference between the Female students (as % of total students) in Tertiary education in 1997 and the Female students (as % of total students) in Secondary vocational education in 1999?
Your response must be concise. 4.12. What is the difference between the Female students (as % of total students) of Secondary general education in 1997 and the Female students (as % of total students) of Secondary vocational education in 1999?
Offer a terse response. 5.01. What is the difference between the Female students (as % of total students) of Primary education in 1998 and the Female students (as % of total students) of Tertiary education in 1999?
Your answer should be very brief. -4.18. What is the difference between the Female students (as % of total students) in Primary education in 1998 and the Female students (as % of total students) in Secondary general education in 1999?
Offer a terse response. -5.84. What is the difference between the Female students (as % of total students) of Primary education in 1998 and the Female students (as % of total students) of Secondary vocational education in 1999?
Offer a terse response. 2.33. What is the difference between the Female students (as % of total students) of Tertiary education in 1998 and the Female students (as % of total students) of Secondary general education in 1999?
Provide a succinct answer. -1.65. What is the difference between the Female students (as % of total students) in Tertiary education in 1998 and the Female students (as % of total students) in Secondary vocational education in 1999?
Offer a terse response. 6.52. What is the difference between the Female students (as % of total students) in Secondary general education in 1998 and the Female students (as % of total students) in Secondary vocational education in 1999?
Your response must be concise. 7.3. What is the average Female students (as % of total students) of Primary education per year?
Provide a short and direct response. 48.42. What is the average Female students (as % of total students) of Tertiary education per year?
Provide a short and direct response. 49.75. What is the average Female students (as % of total students) in Secondary general education per year?
Offer a terse response. 51.22. What is the average Female students (as % of total students) of Secondary vocational education per year?
Your answer should be compact. 40.47. In the year 1991, what is the difference between the Female students (as % of total students) in Primary education and Female students (as % of total students) in Tertiary education?
Your answer should be very brief. 1.92. In the year 1991, what is the difference between the Female students (as % of total students) in Primary education and Female students (as % of total students) in Secondary general education?
Your response must be concise. -0.6. In the year 1991, what is the difference between the Female students (as % of total students) of Primary education and Female students (as % of total students) of Secondary vocational education?
Offer a very short reply. 14.75. In the year 1991, what is the difference between the Female students (as % of total students) of Tertiary education and Female students (as % of total students) of Secondary general education?
Provide a short and direct response. -2.53. In the year 1991, what is the difference between the Female students (as % of total students) in Tertiary education and Female students (as % of total students) in Secondary vocational education?
Your response must be concise. 12.83. In the year 1991, what is the difference between the Female students (as % of total students) in Secondary general education and Female students (as % of total students) in Secondary vocational education?
Provide a succinct answer. 15.36. In the year 1992, what is the difference between the Female students (as % of total students) of Primary education and Female students (as % of total students) of Tertiary education?
Make the answer very short. 0.63. In the year 1992, what is the difference between the Female students (as % of total students) of Primary education and Female students (as % of total students) of Secondary general education?
Your answer should be very brief. -0.93. In the year 1992, what is the difference between the Female students (as % of total students) of Primary education and Female students (as % of total students) of Secondary vocational education?
Provide a short and direct response. 12.59. In the year 1992, what is the difference between the Female students (as % of total students) in Tertiary education and Female students (as % of total students) in Secondary general education?
Your answer should be very brief. -1.56. In the year 1992, what is the difference between the Female students (as % of total students) of Tertiary education and Female students (as % of total students) of Secondary vocational education?
Offer a very short reply. 11.96. In the year 1992, what is the difference between the Female students (as % of total students) in Secondary general education and Female students (as % of total students) in Secondary vocational education?
Your answer should be very brief. 13.52. In the year 1994, what is the difference between the Female students (as % of total students) in Primary education and Female students (as % of total students) in Tertiary education?
Make the answer very short. -0.41. In the year 1994, what is the difference between the Female students (as % of total students) in Primary education and Female students (as % of total students) in Secondary general education?
Offer a very short reply. -1.99. In the year 1994, what is the difference between the Female students (as % of total students) of Primary education and Female students (as % of total students) of Secondary vocational education?
Your answer should be very brief. 12.98. In the year 1994, what is the difference between the Female students (as % of total students) of Tertiary education and Female students (as % of total students) of Secondary general education?
Provide a succinct answer. -1.59. In the year 1994, what is the difference between the Female students (as % of total students) in Tertiary education and Female students (as % of total students) in Secondary vocational education?
Your answer should be compact. 13.39. In the year 1994, what is the difference between the Female students (as % of total students) in Secondary general education and Female students (as % of total students) in Secondary vocational education?
Provide a succinct answer. 14.98. In the year 1995, what is the difference between the Female students (as % of total students) of Primary education and Female students (as % of total students) of Tertiary education?
Give a very brief answer. -3.21. In the year 1995, what is the difference between the Female students (as % of total students) of Primary education and Female students (as % of total students) of Secondary general education?
Give a very brief answer. -4.87. In the year 1995, what is the difference between the Female students (as % of total students) in Primary education and Female students (as % of total students) in Secondary vocational education?
Your answer should be compact. 6.67. In the year 1995, what is the difference between the Female students (as % of total students) of Tertiary education and Female students (as % of total students) of Secondary general education?
Provide a succinct answer. -1.66. In the year 1995, what is the difference between the Female students (as % of total students) of Tertiary education and Female students (as % of total students) of Secondary vocational education?
Provide a short and direct response. 9.88. In the year 1995, what is the difference between the Female students (as % of total students) in Secondary general education and Female students (as % of total students) in Secondary vocational education?
Offer a very short reply. 11.55. In the year 1996, what is the difference between the Female students (as % of total students) of Primary education and Female students (as % of total students) of Tertiary education?
Offer a terse response. -3.13. In the year 1996, what is the difference between the Female students (as % of total students) of Primary education and Female students (as % of total students) of Secondary general education?
Ensure brevity in your answer.  -4.23. In the year 1996, what is the difference between the Female students (as % of total students) in Primary education and Female students (as % of total students) in Secondary vocational education?
Provide a short and direct response. 5.44. In the year 1996, what is the difference between the Female students (as % of total students) of Tertiary education and Female students (as % of total students) of Secondary general education?
Your answer should be compact. -1.09. In the year 1996, what is the difference between the Female students (as % of total students) of Tertiary education and Female students (as % of total students) of Secondary vocational education?
Offer a very short reply. 8.57. In the year 1996, what is the difference between the Female students (as % of total students) of Secondary general education and Female students (as % of total students) of Secondary vocational education?
Your answer should be compact. 9.66. In the year 1997, what is the difference between the Female students (as % of total students) of Primary education and Female students (as % of total students) of Tertiary education?
Your answer should be very brief. -1.21. In the year 1997, what is the difference between the Female students (as % of total students) in Primary education and Female students (as % of total students) in Secondary general education?
Your answer should be very brief. -2.1. In the year 1997, what is the difference between the Female students (as % of total students) of Primary education and Female students (as % of total students) of Secondary vocational education?
Offer a very short reply. 4.62. In the year 1997, what is the difference between the Female students (as % of total students) in Tertiary education and Female students (as % of total students) in Secondary general education?
Keep it short and to the point. -0.89. In the year 1997, what is the difference between the Female students (as % of total students) of Tertiary education and Female students (as % of total students) of Secondary vocational education?
Your response must be concise. 5.83. In the year 1997, what is the difference between the Female students (as % of total students) of Secondary general education and Female students (as % of total students) of Secondary vocational education?
Provide a succinct answer. 6.72. In the year 1998, what is the difference between the Female students (as % of total students) of Primary education and Female students (as % of total students) of Tertiary education?
Your answer should be compact. -4.19. In the year 1998, what is the difference between the Female students (as % of total students) in Primary education and Female students (as % of total students) in Secondary general education?
Provide a short and direct response. -4.97. In the year 1998, what is the difference between the Female students (as % of total students) in Primary education and Female students (as % of total students) in Secondary vocational education?
Offer a terse response. 1.08. In the year 1998, what is the difference between the Female students (as % of total students) in Tertiary education and Female students (as % of total students) in Secondary general education?
Offer a terse response. -0.78. In the year 1998, what is the difference between the Female students (as % of total students) of Tertiary education and Female students (as % of total students) of Secondary vocational education?
Your answer should be very brief. 5.28. In the year 1998, what is the difference between the Female students (as % of total students) in Secondary general education and Female students (as % of total students) in Secondary vocational education?
Make the answer very short. 6.05. In the year 1999, what is the difference between the Female students (as % of total students) of Primary education and Female students (as % of total students) of Tertiary education?
Your response must be concise. -1. In the year 1999, what is the difference between the Female students (as % of total students) in Primary education and Female students (as % of total students) in Secondary general education?
Your answer should be very brief. -2.67. In the year 1999, what is the difference between the Female students (as % of total students) of Primary education and Female students (as % of total students) of Secondary vocational education?
Provide a short and direct response. 5.5. In the year 1999, what is the difference between the Female students (as % of total students) of Tertiary education and Female students (as % of total students) of Secondary general education?
Provide a succinct answer. -1.66. In the year 1999, what is the difference between the Female students (as % of total students) of Tertiary education and Female students (as % of total students) of Secondary vocational education?
Your answer should be compact. 6.5. In the year 1999, what is the difference between the Female students (as % of total students) in Secondary general education and Female students (as % of total students) in Secondary vocational education?
Your response must be concise. 8.17. What is the ratio of the Female students (as % of total students) of Primary education in 1991 to that in 1992?
Your answer should be very brief. 1.03. What is the ratio of the Female students (as % of total students) in Secondary general education in 1991 to that in 1992?
Ensure brevity in your answer.  1.02. What is the ratio of the Female students (as % of total students) of Primary education in 1991 to that in 1994?
Offer a terse response. 1.03. What is the ratio of the Female students (as % of total students) in Tertiary education in 1991 to that in 1994?
Offer a terse response. 0.99. What is the ratio of the Female students (as % of total students) in Secondary general education in 1991 to that in 1994?
Ensure brevity in your answer.  1. What is the ratio of the Female students (as % of total students) in Secondary vocational education in 1991 to that in 1994?
Your response must be concise. 1. What is the ratio of the Female students (as % of total students) in Primary education in 1991 to that in 1995?
Your response must be concise. 1.07. What is the ratio of the Female students (as % of total students) of Tertiary education in 1991 to that in 1995?
Ensure brevity in your answer.  0.97. What is the ratio of the Female students (as % of total students) in Secondary general education in 1991 to that in 1995?
Offer a terse response. 0.98. What is the ratio of the Female students (as % of total students) of Secondary vocational education in 1991 to that in 1995?
Provide a short and direct response. 0.89. What is the ratio of the Female students (as % of total students) in Primary education in 1991 to that in 1996?
Make the answer very short. 1.07. What is the ratio of the Female students (as % of total students) in Tertiary education in 1991 to that in 1996?
Your answer should be very brief. 0.96. What is the ratio of the Female students (as % of total students) of Secondary general education in 1991 to that in 1996?
Your answer should be compact. 0.99. What is the ratio of the Female students (as % of total students) in Secondary vocational education in 1991 to that in 1996?
Your response must be concise. 0.85. What is the ratio of the Female students (as % of total students) in Primary education in 1991 to that in 1997?
Provide a succinct answer. 1.07. What is the ratio of the Female students (as % of total students) in Tertiary education in 1991 to that in 1997?
Provide a succinct answer. 1. What is the ratio of the Female students (as % of total students) in Secondary general education in 1991 to that in 1997?
Provide a succinct answer. 1.04. What is the ratio of the Female students (as % of total students) in Secondary vocational education in 1991 to that in 1997?
Your answer should be compact. 0.84. What is the ratio of the Female students (as % of total students) of Primary education in 1991 to that in 1998?
Provide a short and direct response. 1.08. What is the ratio of the Female students (as % of total students) in Tertiary education in 1991 to that in 1998?
Ensure brevity in your answer.  0.96. What is the ratio of the Female students (as % of total students) in Secondary general education in 1991 to that in 1998?
Ensure brevity in your answer.  0.99. What is the ratio of the Female students (as % of total students) in Secondary vocational education in 1991 to that in 1998?
Your response must be concise. 0.79. What is the ratio of the Female students (as % of total students) of Primary education in 1991 to that in 1999?
Make the answer very short. 1.01. What is the ratio of the Female students (as % of total students) in Tertiary education in 1991 to that in 1999?
Provide a succinct answer. 0.96. What is the ratio of the Female students (as % of total students) of Secondary general education in 1991 to that in 1999?
Make the answer very short. 0.97. What is the ratio of the Female students (as % of total students) of Secondary vocational education in 1991 to that in 1999?
Make the answer very short. 0.81. What is the ratio of the Female students (as % of total students) of Primary education in 1992 to that in 1994?
Keep it short and to the point. 1.01. What is the ratio of the Female students (as % of total students) in Tertiary education in 1992 to that in 1994?
Provide a short and direct response. 0.99. What is the ratio of the Female students (as % of total students) of Secondary general education in 1992 to that in 1994?
Offer a terse response. 0.99. What is the ratio of the Female students (as % of total students) of Secondary vocational education in 1992 to that in 1994?
Your answer should be compact. 1.02. What is the ratio of the Female students (as % of total students) in Primary education in 1992 to that in 1995?
Your response must be concise. 1.05. What is the ratio of the Female students (as % of total students) in Tertiary education in 1992 to that in 1995?
Keep it short and to the point. 0.97. What is the ratio of the Female students (as % of total students) of Secondary vocational education in 1992 to that in 1995?
Your response must be concise. 0.91. What is the ratio of the Female students (as % of total students) of Primary education in 1992 to that in 1996?
Give a very brief answer. 1.04. What is the ratio of the Female students (as % of total students) of Tertiary education in 1992 to that in 1996?
Keep it short and to the point. 0.96. What is the ratio of the Female students (as % of total students) of Secondary general education in 1992 to that in 1996?
Offer a very short reply. 0.97. What is the ratio of the Female students (as % of total students) of Secondary vocational education in 1992 to that in 1996?
Offer a terse response. 0.88. What is the ratio of the Female students (as % of total students) in Primary education in 1992 to that in 1997?
Your answer should be compact. 1.04. What is the ratio of the Female students (as % of total students) of Secondary general education in 1992 to that in 1997?
Provide a short and direct response. 1.02. What is the ratio of the Female students (as % of total students) in Secondary vocational education in 1992 to that in 1997?
Your answer should be compact. 0.86. What is the ratio of the Female students (as % of total students) in Primary education in 1992 to that in 1998?
Give a very brief answer. 1.06. What is the ratio of the Female students (as % of total students) in Tertiary education in 1992 to that in 1998?
Offer a very short reply. 0.96. What is the ratio of the Female students (as % of total students) of Secondary general education in 1992 to that in 1998?
Keep it short and to the point. 0.97. What is the ratio of the Female students (as % of total students) of Secondary vocational education in 1992 to that in 1998?
Offer a terse response. 0.81. What is the ratio of the Female students (as % of total students) of Primary education in 1992 to that in 1999?
Your answer should be compact. 0.99. What is the ratio of the Female students (as % of total students) of Tertiary education in 1992 to that in 1999?
Your answer should be compact. 0.96. What is the ratio of the Female students (as % of total students) of Secondary general education in 1992 to that in 1999?
Provide a short and direct response. 0.96. What is the ratio of the Female students (as % of total students) of Secondary vocational education in 1992 to that in 1999?
Make the answer very short. 0.83. What is the ratio of the Female students (as % of total students) in Primary education in 1994 to that in 1995?
Provide a short and direct response. 1.04. What is the ratio of the Female students (as % of total students) of Tertiary education in 1994 to that in 1995?
Offer a terse response. 0.98. What is the ratio of the Female students (as % of total students) of Secondary general education in 1994 to that in 1995?
Offer a terse response. 0.98. What is the ratio of the Female students (as % of total students) of Secondary vocational education in 1994 to that in 1995?
Provide a succinct answer. 0.89. What is the ratio of the Female students (as % of total students) of Primary education in 1994 to that in 1996?
Your answer should be compact. 1.03. What is the ratio of the Female students (as % of total students) in Tertiary education in 1994 to that in 1996?
Make the answer very short. 0.98. What is the ratio of the Female students (as % of total students) in Secondary vocational education in 1994 to that in 1996?
Ensure brevity in your answer.  0.86. What is the ratio of the Female students (as % of total students) of Primary education in 1994 to that in 1997?
Your answer should be compact. 1.04. What is the ratio of the Female students (as % of total students) of Tertiary education in 1994 to that in 1997?
Provide a short and direct response. 1.02. What is the ratio of the Female students (as % of total students) of Secondary general education in 1994 to that in 1997?
Provide a succinct answer. 1.03. What is the ratio of the Female students (as % of total students) in Secondary vocational education in 1994 to that in 1997?
Your answer should be compact. 0.84. What is the ratio of the Female students (as % of total students) of Primary education in 1994 to that in 1998?
Make the answer very short. 1.05. What is the ratio of the Female students (as % of total students) in Tertiary education in 1994 to that in 1998?
Provide a succinct answer. 0.97. What is the ratio of the Female students (as % of total students) in Secondary vocational education in 1994 to that in 1998?
Provide a short and direct response. 0.79. What is the ratio of the Female students (as % of total students) in Primary education in 1994 to that in 1999?
Offer a very short reply. 0.98. What is the ratio of the Female students (as % of total students) in Tertiary education in 1994 to that in 1999?
Provide a succinct answer. 0.97. What is the ratio of the Female students (as % of total students) in Secondary general education in 1994 to that in 1999?
Keep it short and to the point. 0.97. What is the ratio of the Female students (as % of total students) of Secondary vocational education in 1994 to that in 1999?
Make the answer very short. 0.81. What is the ratio of the Female students (as % of total students) in Secondary general education in 1995 to that in 1996?
Give a very brief answer. 1.01. What is the ratio of the Female students (as % of total students) in Secondary vocational education in 1995 to that in 1996?
Make the answer very short. 0.96. What is the ratio of the Female students (as % of total students) in Primary education in 1995 to that in 1997?
Give a very brief answer. 1. What is the ratio of the Female students (as % of total students) of Tertiary education in 1995 to that in 1997?
Give a very brief answer. 1.04. What is the ratio of the Female students (as % of total students) of Secondary general education in 1995 to that in 1997?
Make the answer very short. 1.05. What is the ratio of the Female students (as % of total students) of Secondary vocational education in 1995 to that in 1997?
Offer a terse response. 0.95. What is the ratio of the Female students (as % of total students) of Primary education in 1995 to that in 1998?
Your answer should be compact. 1.01. What is the ratio of the Female students (as % of total students) in Tertiary education in 1995 to that in 1998?
Keep it short and to the point. 0.99. What is the ratio of the Female students (as % of total students) in Secondary general education in 1995 to that in 1998?
Your answer should be very brief. 1.01. What is the ratio of the Female students (as % of total students) of Secondary vocational education in 1995 to that in 1998?
Your answer should be very brief. 0.89. What is the ratio of the Female students (as % of total students) of Primary education in 1995 to that in 1999?
Your answer should be very brief. 0.94. What is the ratio of the Female students (as % of total students) of Tertiary education in 1995 to that in 1999?
Your response must be concise. 0.99. What is the ratio of the Female students (as % of total students) in Secondary general education in 1995 to that in 1999?
Make the answer very short. 0.99. What is the ratio of the Female students (as % of total students) in Secondary vocational education in 1995 to that in 1999?
Your response must be concise. 0.91. What is the ratio of the Female students (as % of total students) in Tertiary education in 1996 to that in 1997?
Your answer should be compact. 1.04. What is the ratio of the Female students (as % of total students) in Secondary general education in 1996 to that in 1997?
Give a very brief answer. 1.04. What is the ratio of the Female students (as % of total students) in Secondary vocational education in 1996 to that in 1997?
Your answer should be compact. 0.98. What is the ratio of the Female students (as % of total students) in Primary education in 1996 to that in 1998?
Provide a succinct answer. 1.01. What is the ratio of the Female students (as % of total students) of Secondary vocational education in 1996 to that in 1998?
Make the answer very short. 0.92. What is the ratio of the Female students (as % of total students) in Primary education in 1996 to that in 1999?
Keep it short and to the point. 0.95. What is the ratio of the Female students (as % of total students) in Secondary general education in 1996 to that in 1999?
Keep it short and to the point. 0.98. What is the ratio of the Female students (as % of total students) in Secondary vocational education in 1996 to that in 1999?
Offer a terse response. 0.94. What is the ratio of the Female students (as % of total students) in Primary education in 1997 to that in 1998?
Give a very brief answer. 1.01. What is the ratio of the Female students (as % of total students) of Tertiary education in 1997 to that in 1998?
Offer a very short reply. 0.95. What is the ratio of the Female students (as % of total students) of Secondary general education in 1997 to that in 1998?
Make the answer very short. 0.96. What is the ratio of the Female students (as % of total students) in Secondary vocational education in 1997 to that in 1998?
Provide a succinct answer. 0.94. What is the ratio of the Female students (as % of total students) in Primary education in 1997 to that in 1999?
Offer a very short reply. 0.95. What is the ratio of the Female students (as % of total students) of Tertiary education in 1997 to that in 1999?
Provide a short and direct response. 0.95. What is the ratio of the Female students (as % of total students) in Secondary vocational education in 1997 to that in 1999?
Ensure brevity in your answer.  0.96. What is the ratio of the Female students (as % of total students) in Primary education in 1998 to that in 1999?
Ensure brevity in your answer.  0.94. What is the ratio of the Female students (as % of total students) of Tertiary education in 1998 to that in 1999?
Your answer should be very brief. 1. What is the ratio of the Female students (as % of total students) of Secondary general education in 1998 to that in 1999?
Offer a very short reply. 0.98. What is the ratio of the Female students (as % of total students) in Secondary vocational education in 1998 to that in 1999?
Ensure brevity in your answer.  1.03. What is the difference between the highest and the second highest Female students (as % of total students) of Primary education?
Provide a short and direct response. 0.69. What is the difference between the highest and the second highest Female students (as % of total students) in Tertiary education?
Your answer should be compact. 0.01. What is the difference between the highest and the second highest Female students (as % of total students) in Secondary general education?
Offer a very short reply. 0.58. What is the difference between the highest and the second highest Female students (as % of total students) in Secondary vocational education?
Make the answer very short. 1.24. What is the difference between the highest and the lowest Female students (as % of total students) in Primary education?
Provide a succinct answer. 3.86. What is the difference between the highest and the lowest Female students (as % of total students) of Tertiary education?
Offer a terse response. 2.4. What is the difference between the highest and the lowest Female students (as % of total students) in Secondary general education?
Your response must be concise. 3.15. What is the difference between the highest and the lowest Female students (as % of total students) in Secondary vocational education?
Make the answer very short. 9.8. 